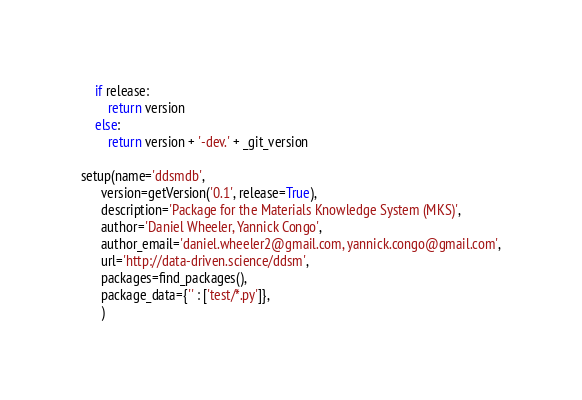<code> <loc_0><loc_0><loc_500><loc_500><_Python_>    if release:
        return version
    else:
        return version + '-dev.' + _git_version

setup(name='ddsmdb',
      version=getVersion('0.1', release=True),
      description='Package for the Materials Knowledge System (MKS)',
      author='Daniel Wheeler, Yannick Congo',
      author_email='daniel.wheeler2@gmail.com, yannick.congo@gmail.com',
      url='http://data-driven.science/ddsm',
      packages=find_packages(),
      package_data={'' : ['test/*.py']},
      )</code> 